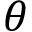Convert formula to latex. <formula><loc_0><loc_0><loc_500><loc_500>\theta</formula> 